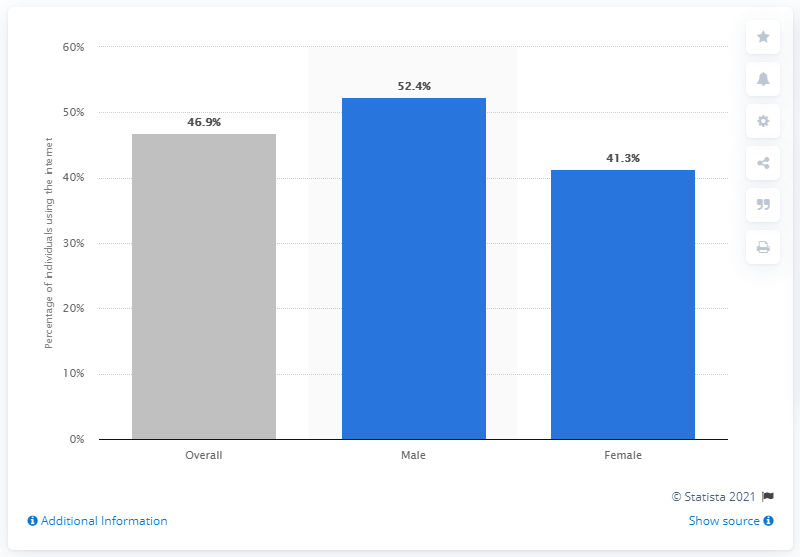Highlight a few significant elements in this photo. In 2018, 46.9% of Egyptians used the internet. In 2018, it was estimated that 52.4% of males used the internet. In 2018, 41.3% of the female population in Egypt had internet access. 